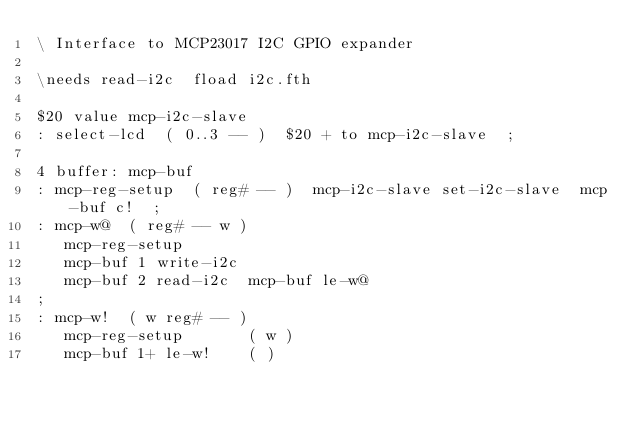<code> <loc_0><loc_0><loc_500><loc_500><_Forth_>\ Interface to MCP23017 I2C GPIO expander

\needs read-i2c  fload i2c.fth

$20 value mcp-i2c-slave
: select-lcd  ( 0..3 -- )  $20 + to mcp-i2c-slave  ;

4 buffer: mcp-buf
: mcp-reg-setup  ( reg# -- )  mcp-i2c-slave set-i2c-slave  mcp-buf c!  ;
: mcp-w@  ( reg# -- w )
   mcp-reg-setup
   mcp-buf 1 write-i2c
   mcp-buf 2 read-i2c  mcp-buf le-w@
;
: mcp-w!  ( w reg# -- )
   mcp-reg-setup       ( w )
   mcp-buf 1+ le-w!    ( )</code> 